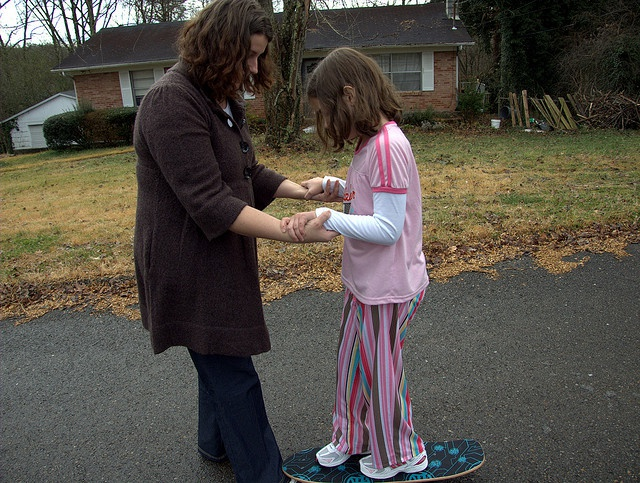Describe the objects in this image and their specific colors. I can see people in lavender, black, and gray tones, people in lavender, darkgray, black, and gray tones, and skateboard in lavender, black, teal, navy, and gray tones in this image. 